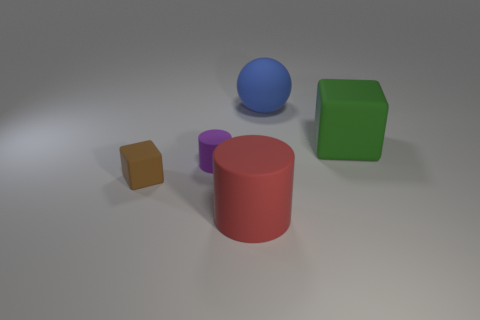Add 3 brown rubber things. How many objects exist? 8 Subtract all cylinders. How many objects are left? 3 Subtract all large cubes. Subtract all green matte cubes. How many objects are left? 3 Add 3 red cylinders. How many red cylinders are left? 4 Add 5 blue spheres. How many blue spheres exist? 6 Subtract 0 blue blocks. How many objects are left? 5 